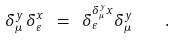<formula> <loc_0><loc_0><loc_500><loc_500>\delta ^ { y } _ { \mu } \, \delta ^ { x } _ { \varepsilon } \ = \ \delta ^ { \delta ^ { y } _ { \mu } x } _ { \varepsilon } \delta ^ { y } _ { \mu } \quad .</formula> 